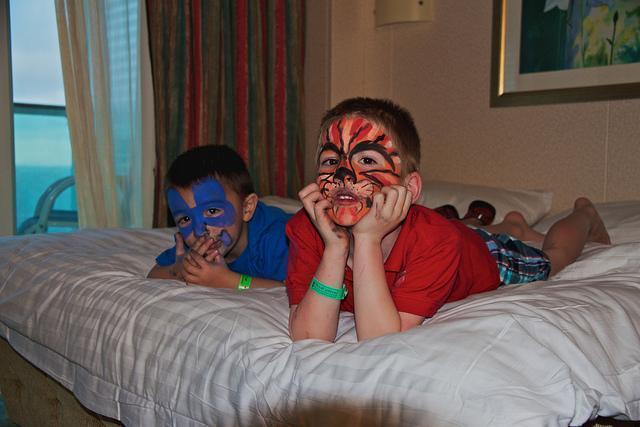Where are these children located?
From the following four choices, select the correct answer to address the question.
Options: Hotel, hospital, classroom, playground. Hotel. 